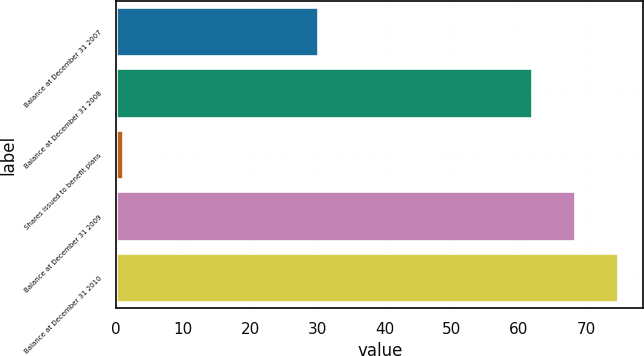Convert chart. <chart><loc_0><loc_0><loc_500><loc_500><bar_chart><fcel>Balance at December 31 2007<fcel>Balance at December 31 2008<fcel>Shares issued to benefit plans<fcel>Balance at December 31 2009<fcel>Balance at December 31 2010<nl><fcel>30<fcel>62<fcel>1<fcel>68.4<fcel>74.8<nl></chart> 